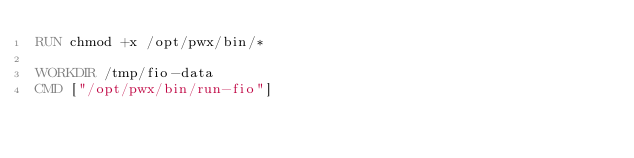Convert code to text. <code><loc_0><loc_0><loc_500><loc_500><_Dockerfile_>RUN chmod +x /opt/pwx/bin/*

WORKDIR /tmp/fio-data
CMD ["/opt/pwx/bin/run-fio"] 
</code> 